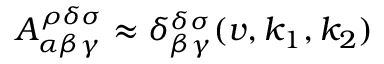Convert formula to latex. <formula><loc_0><loc_0><loc_500><loc_500>A _ { \alpha \beta \gamma } ^ { \rho \delta \sigma } \approx \delta _ { \beta \gamma } ^ { \delta \sigma } ( v , k _ { 1 } , k _ { 2 } )</formula> 